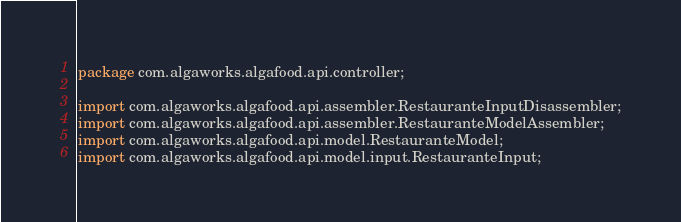Convert code to text. <code><loc_0><loc_0><loc_500><loc_500><_Java_>package com.algaworks.algafood.api.controller;

import com.algaworks.algafood.api.assembler.RestauranteInputDisassembler;
import com.algaworks.algafood.api.assembler.RestauranteModelAssembler;
import com.algaworks.algafood.api.model.RestauranteModel;
import com.algaworks.algafood.api.model.input.RestauranteInput;</code> 